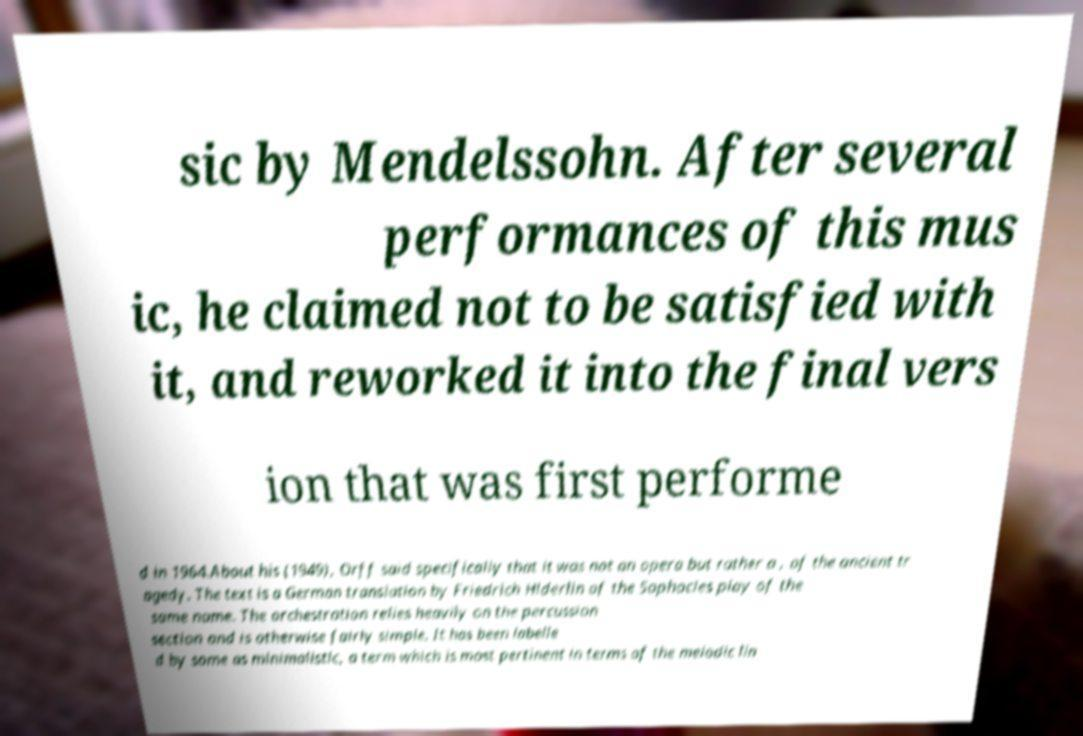Could you assist in decoding the text presented in this image and type it out clearly? sic by Mendelssohn. After several performances of this mus ic, he claimed not to be satisfied with it, and reworked it into the final vers ion that was first performe d in 1964.About his (1949), Orff said specifically that it was not an opera but rather a , of the ancient tr agedy. The text is a German translation by Friedrich Hlderlin of the Sophocles play of the same name. The orchestration relies heavily on the percussion section and is otherwise fairly simple. It has been labelle d by some as minimalistic, a term which is most pertinent in terms of the melodic lin 